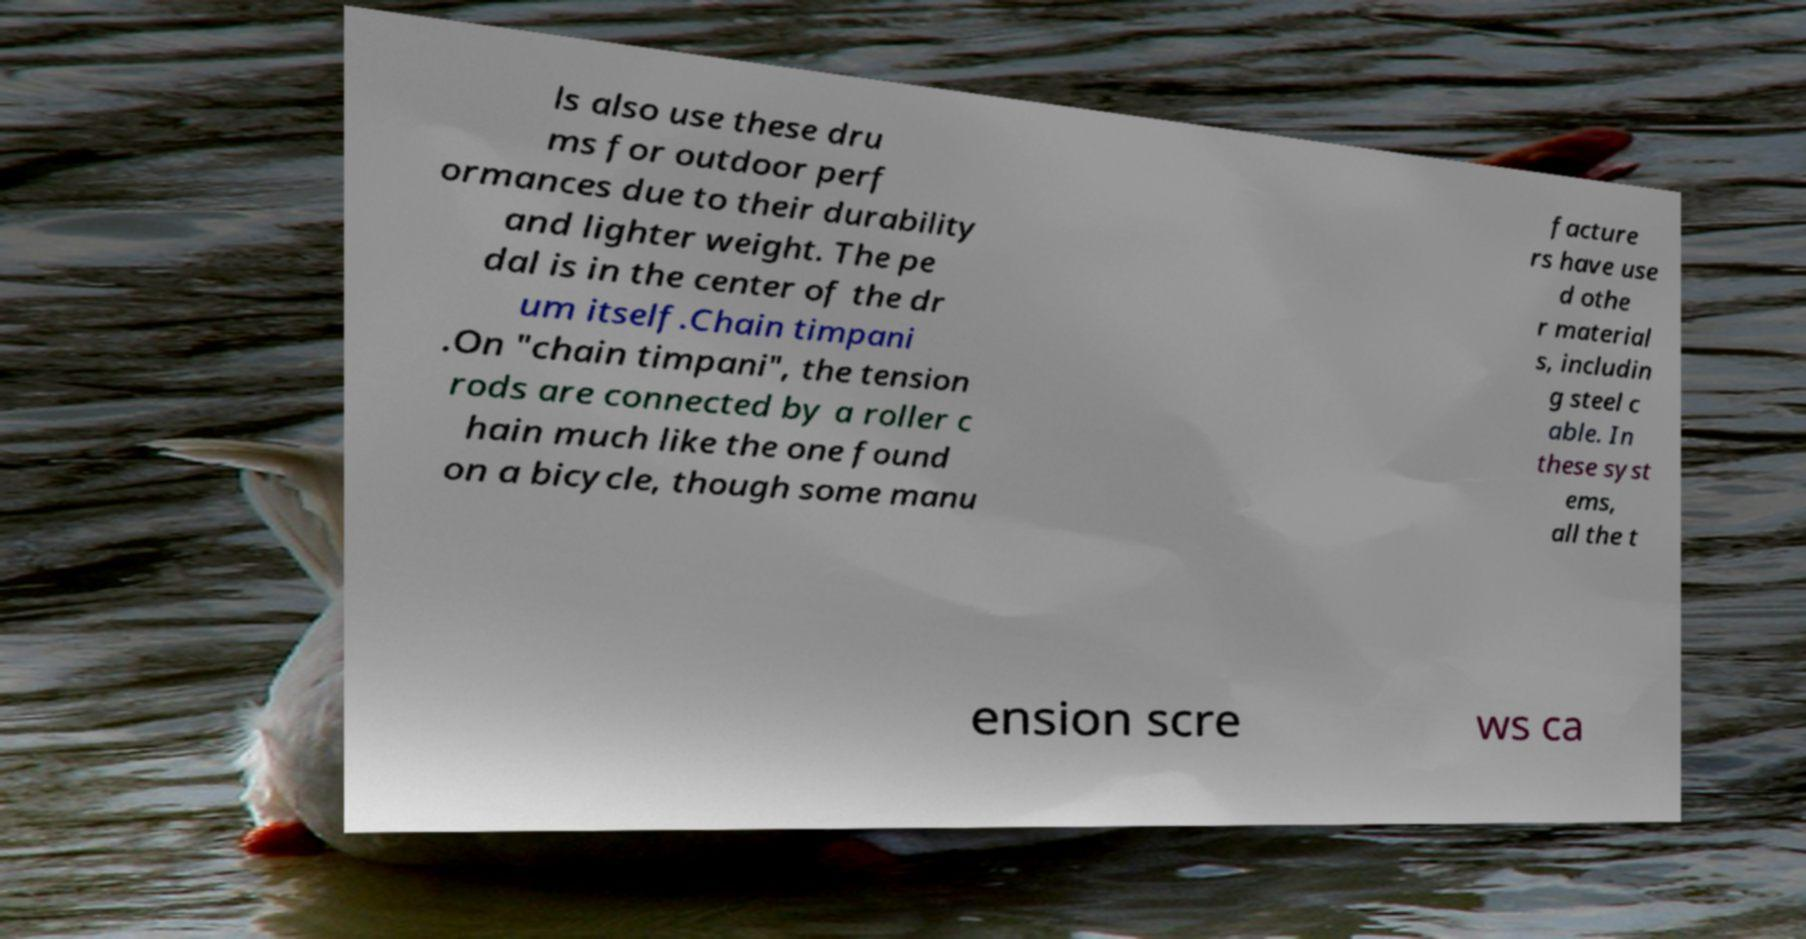Could you extract and type out the text from this image? ls also use these dru ms for outdoor perf ormances due to their durability and lighter weight. The pe dal is in the center of the dr um itself.Chain timpani .On "chain timpani", the tension rods are connected by a roller c hain much like the one found on a bicycle, though some manu facture rs have use d othe r material s, includin g steel c able. In these syst ems, all the t ension scre ws ca 